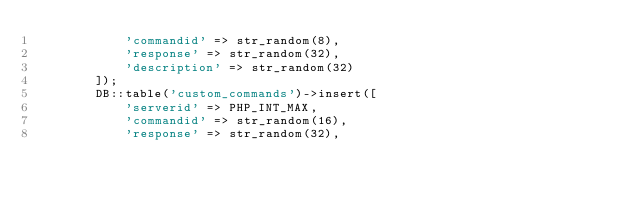Convert code to text. <code><loc_0><loc_0><loc_500><loc_500><_PHP_>            'commandid' => str_random(8),
            'response' => str_random(32),
            'description' => str_random(32)
        ]);
        DB::table('custom_commands')->insert([
            'serverid' => PHP_INT_MAX,
            'commandid' => str_random(16),
            'response' => str_random(32),</code> 